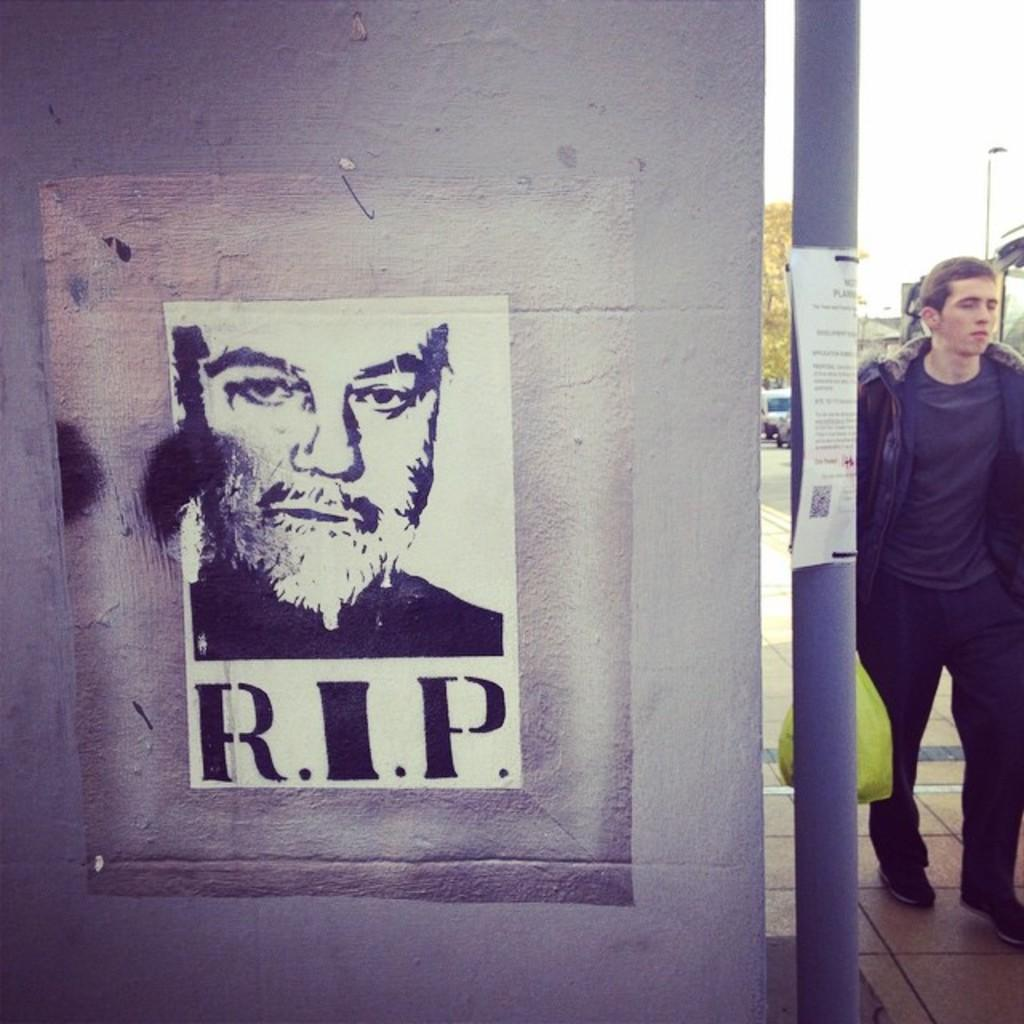What is present on the wall in the image? There is a poster on the wall in the image. What else can be seen on the right side of the image? There is a pole on the right side of the image. Is there a person visible in the image? Yes, there is a man behind the pole in the image. What type of holiday is being celebrated in the image? There is no indication of a holiday being celebrated in the image. What is the man behind the pole eating in the image? There is no food, such as oatmeal, present in the image. 